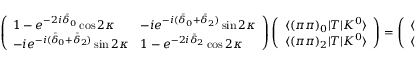Convert formula to latex. <formula><loc_0><loc_0><loc_500><loc_500>\left ( \begin{array} { l l } { { { 1 - e ^ { - 2 i { \bar { \delta } } _ { 0 } } \cos 2 \kappa } } } & { { { - i e ^ { - i ( { \bar { \delta } } _ { 0 } + { \bar { \delta } } _ { 2 } ) } \sin 2 \kappa } } } \\ { { { - i e ^ { - i ( { \bar { \delta } } _ { 0 } + { \bar { \delta } } _ { 2 } ) } \sin 2 \kappa } } } & { { { 1 - e ^ { - 2 i { \bar { \delta } } _ { 2 } } \cos 2 \kappa } } } \end{array} \right ) \left ( \begin{array} { l } { { { \langle ( \pi \pi ) _ { 0 } | T | K ^ { 0 } \rangle } } } \\ { { { \langle ( \pi \pi ) _ { 2 } | T | K ^ { 0 } \rangle } } } \end{array} \right ) = \left ( \begin{array} { l } { { { \langle ( \pi \pi ) _ { 0 } | T | K ^ { 0 } \rangle - \langle ( \pi \pi ) _ { 0 } | T ^ { \dagger } | K ^ { 0 } \rangle } } } \\ { { { \langle ( \pi \pi ) _ { 2 } | T | K ^ { 0 } \rangle - \langle ( \pi \pi ) _ { 2 } | T ^ { \dagger } | K ^ { 0 } \rangle } } } \end{array} \right )</formula> 